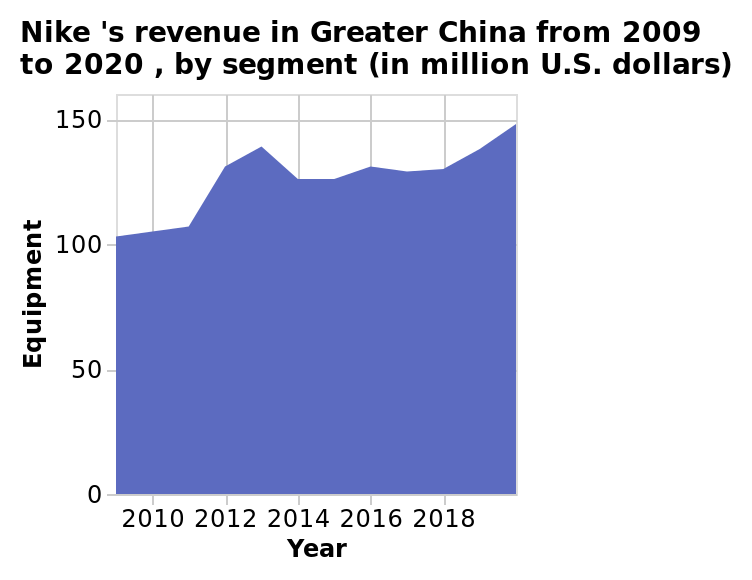<image>
Will Nike continue to increase their revenue? Yes, if Nike continues what they are doing, they will continue to increase their revenue steadily. 